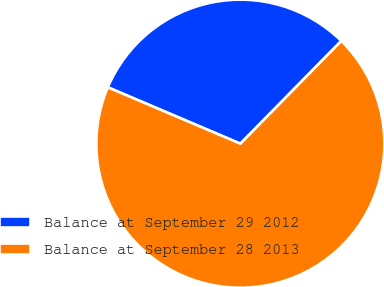<chart> <loc_0><loc_0><loc_500><loc_500><pie_chart><fcel>Balance at September 29 2012<fcel>Balance at September 28 2013<nl><fcel>30.96%<fcel>69.04%<nl></chart> 